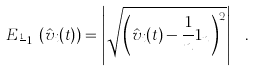Convert formula to latex. <formula><loc_0><loc_0><loc_500><loc_500>E _ { \frac { 1 } { n } 1 _ { n } } ( \hat { v } _ { i } ( t ) ) = \left | \sqrt { \left ( \hat { v } _ { i } ( t ) - \frac { 1 } { n } 1 _ { n } \right ) ^ { 2 } } \right | \ .</formula> 